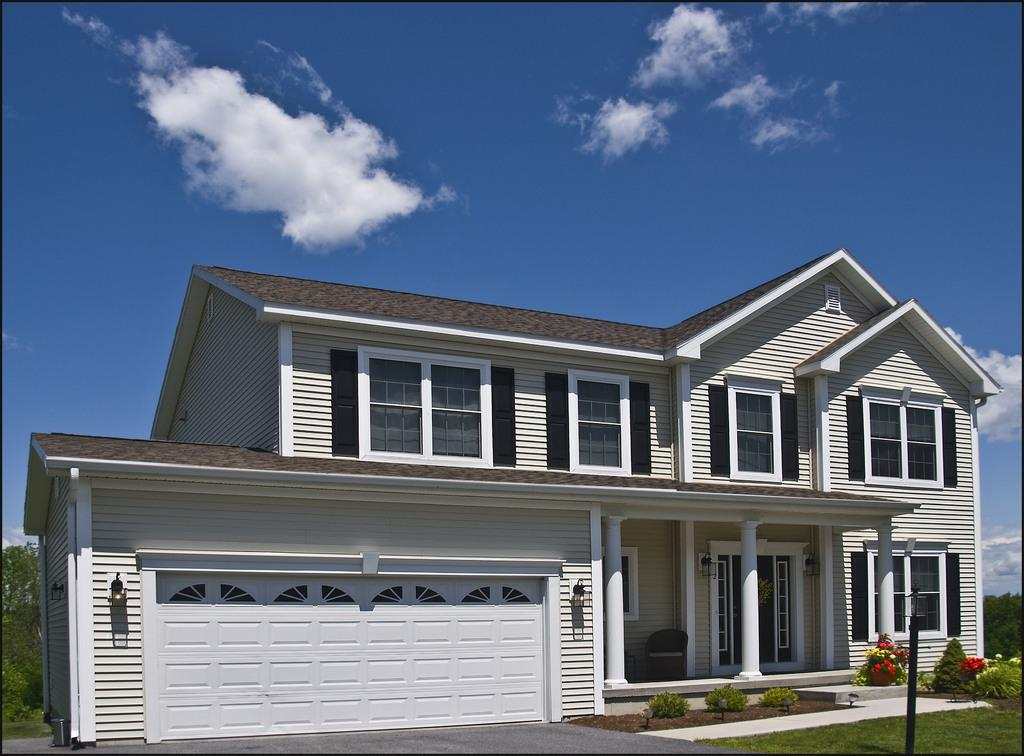What type of structure is present in the image? There is a building in the image. What colors can be seen on the building? The building has white and brown colors. What other natural elements are visible in the image? There are trees in the image. What object can be seen near the building? There is a pole in the image. What type of windows does the building have? The building has glass windows. What can be seen in the sky in the image? The sky is visible in the image and has white and blue colors. How many ears can be seen on the building in the image? There are no ears present on the building in the image. What type of plants are growing on the building in the image? There are no plants growing on the building in the image. 